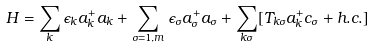Convert formula to latex. <formula><loc_0><loc_0><loc_500><loc_500>H = \sum _ { k } \epsilon _ { k } a ^ { + } _ { k } a _ { k } + \sum _ { \sigma = 1 , m } \epsilon _ { \sigma } a ^ { + } _ { \sigma } a _ { \sigma } + \sum _ { k \sigma } [ T _ { k \sigma } a ^ { + } _ { k } c _ { \sigma } + h . c . ]</formula> 